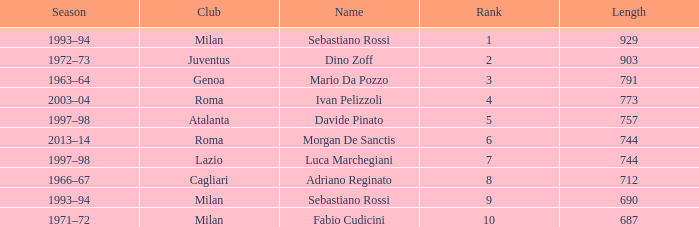What name is associated with a longer length than 903? Sebastiano Rossi. 